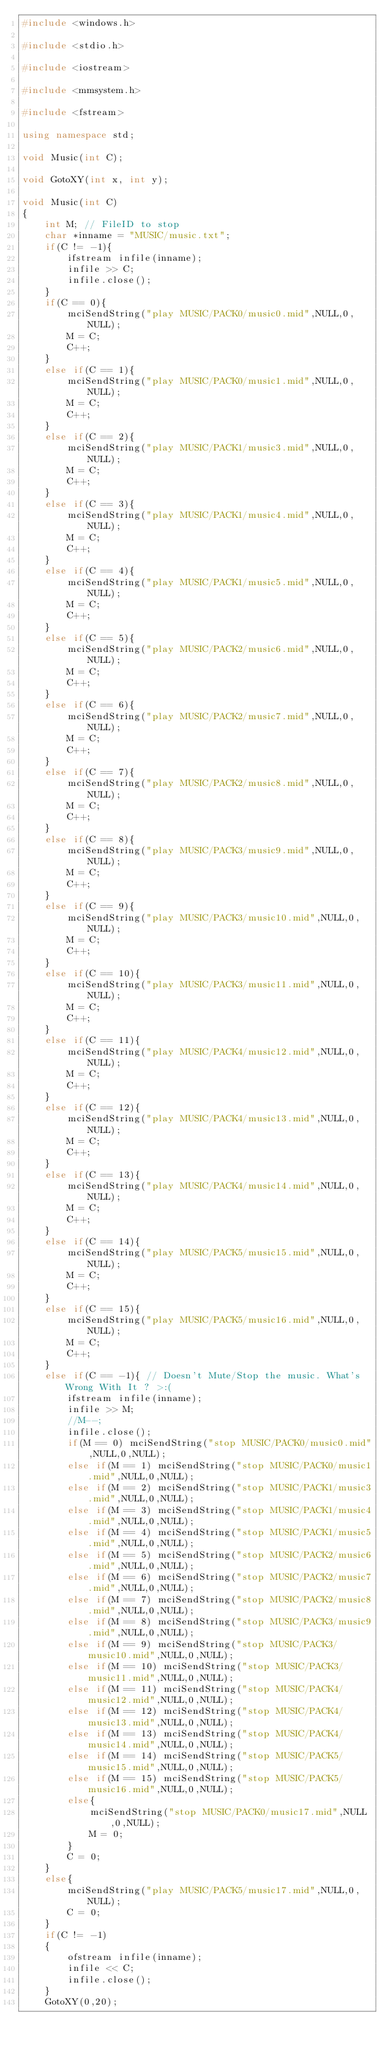Convert code to text. <code><loc_0><loc_0><loc_500><loc_500><_C++_>#include <windows.h>

#include <stdio.h>

#include <iostream>

#include <mmsystem.h>

#include <fstream>

using namespace std;

void Music(int C);

void GotoXY(int x, int y);

void Music(int C)
{
    int M; // FileID to stop
    char *inname = "MUSIC/music.txt";
    if(C != -1){
        ifstream infile(inname);
        infile >> C;
        infile.close();
    }
    if(C == 0){
        mciSendString("play MUSIC/PACK0/music0.mid",NULL,0,NULL);
        M = C;
        C++;
    }
    else if(C == 1){
        mciSendString("play MUSIC/PACK0/music1.mid",NULL,0,NULL);
        M = C;
        C++;
    }
    else if(C == 2){
        mciSendString("play MUSIC/PACK1/music3.mid",NULL,0,NULL);
        M = C;
        C++;
    }
    else if(C == 3){
        mciSendString("play MUSIC/PACK1/music4.mid",NULL,0,NULL);
        M = C;
        C++;
    }
    else if(C == 4){
        mciSendString("play MUSIC/PACK1/music5.mid",NULL,0,NULL);
        M = C;
        C++;
    }
    else if(C == 5){
        mciSendString("play MUSIC/PACK2/music6.mid",NULL,0,NULL);
        M = C;
        C++;
    }
    else if(C == 6){
        mciSendString("play MUSIC/PACK2/music7.mid",NULL,0,NULL);
        M = C;
        C++;
    }
    else if(C == 7){
        mciSendString("play MUSIC/PACK2/music8.mid",NULL,0,NULL);
        M = C;
        C++;
    }
    else if(C == 8){
        mciSendString("play MUSIC/PACK3/music9.mid",NULL,0,NULL);
        M = C;
        C++;
    }
    else if(C == 9){
        mciSendString("play MUSIC/PACK3/music10.mid",NULL,0,NULL);
        M = C;
        C++;
    }
    else if(C == 10){
        mciSendString("play MUSIC/PACK3/music11.mid",NULL,0,NULL);
        M = C;
        C++;
    }
    else if(C == 11){
        mciSendString("play MUSIC/PACK4/music12.mid",NULL,0,NULL);
        M = C;
        C++;
    }
    else if(C == 12){
        mciSendString("play MUSIC/PACK4/music13.mid",NULL,0,NULL);
        M = C;
        C++;
    }
    else if(C == 13){
        mciSendString("play MUSIC/PACK4/music14.mid",NULL,0,NULL);
        M = C;
        C++;
    }
    else if(C == 14){
        mciSendString("play MUSIC/PACK5/music15.mid",NULL,0,NULL);
        M = C;
        C++;
    }
    else if(C == 15){
        mciSendString("play MUSIC/PACK5/music16.mid",NULL,0,NULL);
        M = C;
        C++;
    }
    else if(C == -1){ // Doesn't Mute/Stop the music. What's Wrong With It ? >:(
        ifstream infile(inname);
        infile >> M;
        //M--;
        infile.close();
        if(M == 0) mciSendString("stop MUSIC/PACK0/music0.mid",NULL,0,NULL);
        else if(M == 1) mciSendString("stop MUSIC/PACK0/music1.mid",NULL,0,NULL);
        else if(M == 2) mciSendString("stop MUSIC/PACK1/music3.mid",NULL,0,NULL);
        else if(M == 3) mciSendString("stop MUSIC/PACK1/music4.mid",NULL,0,NULL);
        else if(M == 4) mciSendString("stop MUSIC/PACK1/music5.mid",NULL,0,NULL);
        else if(M == 5) mciSendString("stop MUSIC/PACK2/music6.mid",NULL,0,NULL);
        else if(M == 6) mciSendString("stop MUSIC/PACK2/music7.mid",NULL,0,NULL);
        else if(M == 7) mciSendString("stop MUSIC/PACK2/music8.mid",NULL,0,NULL);
        else if(M == 8) mciSendString("stop MUSIC/PACK3/music9.mid",NULL,0,NULL);
        else if(M == 9) mciSendString("stop MUSIC/PACK3/music10.mid",NULL,0,NULL);
        else if(M == 10) mciSendString("stop MUSIC/PACK3/music11.mid",NULL,0,NULL);
        else if(M == 11) mciSendString("stop MUSIC/PACK4/music12.mid",NULL,0,NULL);
        else if(M == 12) mciSendString("stop MUSIC/PACK4/music13.mid",NULL,0,NULL);
        else if(M == 13) mciSendString("stop MUSIC/PACK4/music14.mid",NULL,0,NULL);
        else if(M == 14) mciSendString("stop MUSIC/PACK5/music15.mid",NULL,0,NULL);
        else if(M == 15) mciSendString("stop MUSIC/PACK5/music16.mid",NULL,0,NULL);
        else{
            mciSendString("stop MUSIC/PACK0/music17.mid",NULL,0,NULL);
            M = 0;
        }
        C = 0;
    }
    else{
        mciSendString("play MUSIC/PACK5/music17.mid",NULL,0,NULL);
        C = 0;
    }
    if(C != -1)
    {
        ofstream infile(inname);
        infile << C;
        infile.close();
    }
    GotoXY(0,20);</code> 